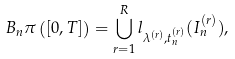<formula> <loc_0><loc_0><loc_500><loc_500>B _ { n } \pi \left ( [ 0 , T ] \right ) = \bigcup _ { r = 1 } ^ { R } l _ { \lambda ^ { ( r ) } , t _ { n } ^ { ( r ) } } ( I _ { n } ^ { ( r ) } ) ,</formula> 